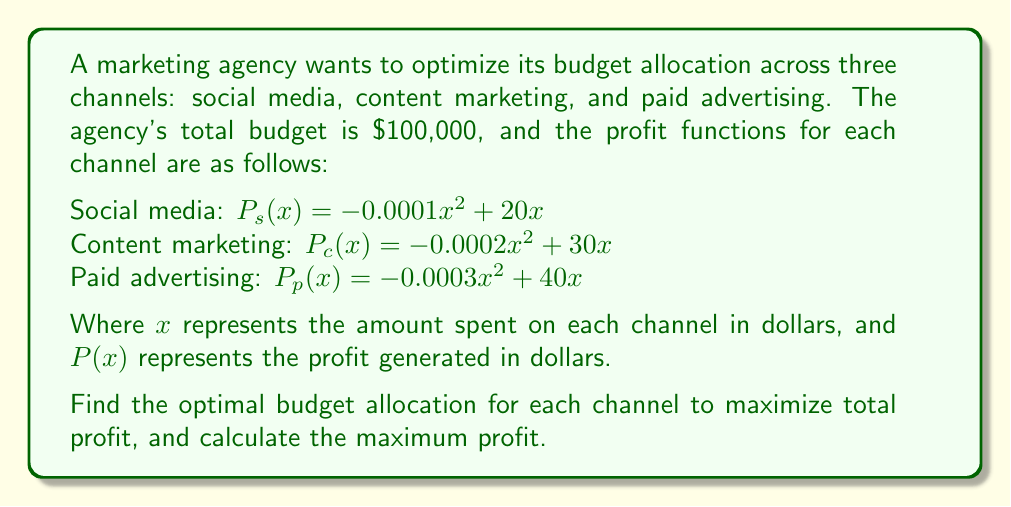Provide a solution to this math problem. To solve this problem, we'll use the method of Lagrange multipliers:

1) Let's define our objective function:
   $f(x_s, x_c, x_p) = P_s(x_s) + P_c(x_c) + P_p(x_p)$
   $= (-0.0001x_s^2 + 20x_s) + (-0.0002x_c^2 + 30x_c) + (-0.0003x_p^2 + 40x_p)$

2) Our constraint is:
   $g(x_s, x_c, x_p) = x_s + x_c + x_p - 100000 = 0$

3) We form the Lagrangian:
   $L(x_s, x_c, x_p, \lambda) = f(x_s, x_c, x_p) - \lambda g(x_s, x_c, x_p)$

4) We take partial derivatives and set them to zero:
   $\frac{\partial L}{\partial x_s} = -0.0002x_s + 20 - \lambda = 0$
   $\frac{\partial L}{\partial x_c} = -0.0004x_c + 30 - \lambda = 0$
   $\frac{\partial L}{\partial x_p} = -0.0006x_p + 40 - \lambda = 0$
   $\frac{\partial L}{\partial \lambda} = x_s + x_c + x_p - 100000 = 0$

5) From these equations, we can derive:
   $x_s = 100000 - \frac{\lambda}{0.0002}$
   $x_c = 75000 - \frac{\lambda}{0.0004}$
   $x_p = 66666.67 - \frac{\lambda}{0.0006}$

6) Substituting these into the constraint equation:
   $(100000 - \frac{\lambda}{0.0002}) + (75000 - \frac{\lambda}{0.0004}) + (66666.67 - \frac{\lambda}{0.0006}) = 100000$

7) Solving this equation:
   $\lambda = 10$

8) Substituting back:
   $x_s = 50000$
   $x_c = 25000$
   $x_p = 25000$

9) The maximum profit is:
   $f(50000, 25000, 25000) = 500000 + 375000 + 500000 = 1375000$
Answer: Social media: $50,000, Content marketing: $25,000, Paid advertising: $25,000. Maximum profit: $1,375,000. 